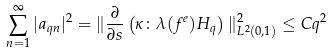<formula> <loc_0><loc_0><loc_500><loc_500>\sum _ { n = 1 } ^ { \infty } | a _ { q n } | ^ { 2 } = \| \frac { \partial } { \partial s } \left ( \kappa \colon \lambda ( f ^ { e } ) H _ { q } \right ) \| _ { L ^ { 2 } ( 0 , 1 ) } ^ { 2 } \leq C q ^ { 2 }</formula> 